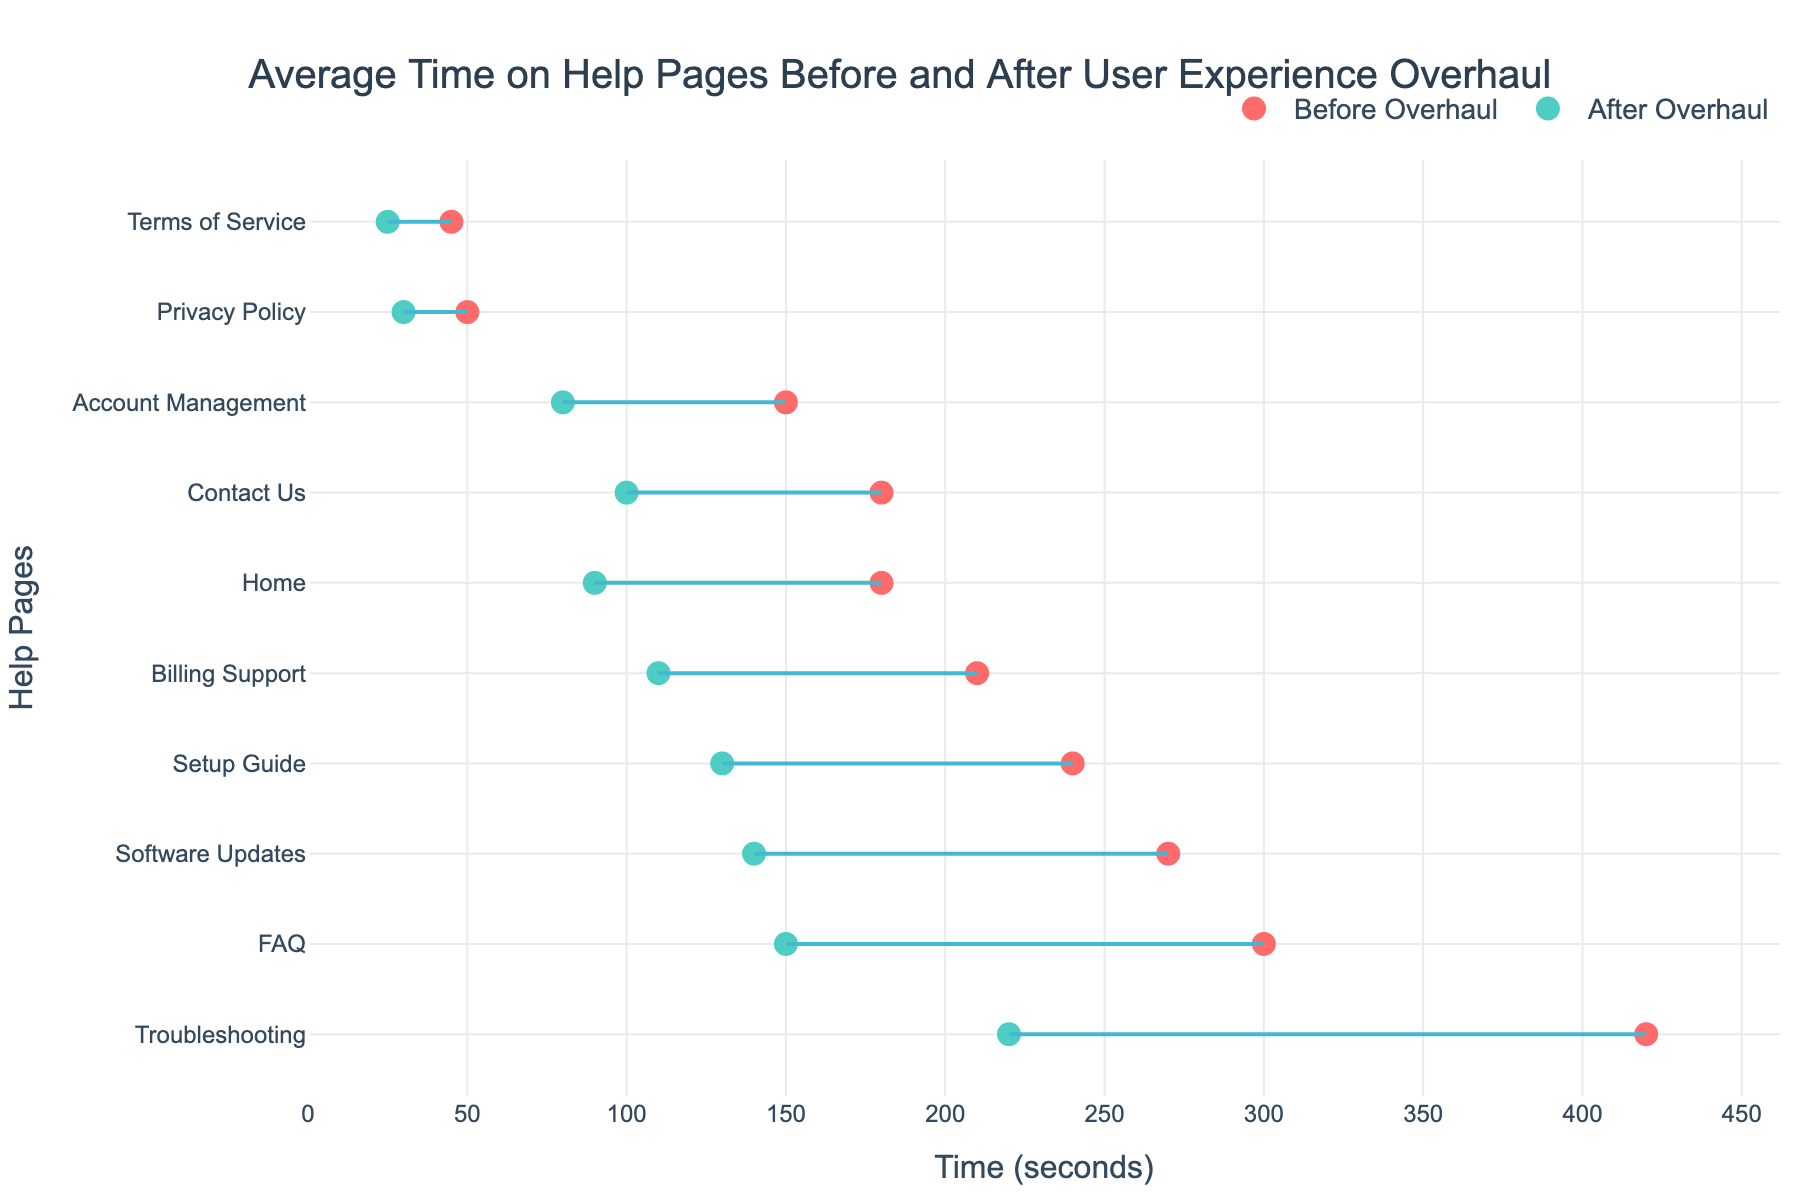What is the range of time users spent on help pages before the overhaul? The range is determined by subtracting the minimum time from the maximum time before the overhaul, which are 45 (Terms of Service) and 420 (Troubleshooting) seconds respectively. 420 - 45 = 375 seconds.
Answer: 375 seconds Which help page saw the greatest reduction in average time after the overhaul? To find this, we compare the difference between "Before Overhaul" and "After Overhaul" for each page. The Troubleshooting page had 420 before and 220 after, resulting in the largest reduction of 200 seconds.
Answer: Troubleshooting How much time did users spend on the Billing Support page after the overhaul? We look at the figure's data points representing the "After Overhaul" time for the Billing Support page. It is shown as 110 seconds.
Answer: 110 seconds Which help page had the smallest improvement in average time spent after the overhaul? To identify the smallest improvement, we look at the page with the lowest difference between "Before Overhaul" and "After Overhaul." The Terms of Service page improved from 45 to 25 seconds, a difference of 20 seconds.
Answer: Terms of Service What categories of help pages are included in the plot? By examining the labels alongside each help page in the figure, we identify the categories as: General Inquiry, Installation, Technical Support, Purchases, Account Related, Legal.
Answer: General Inquiry, Installation, Technical Support, Purchases, Account Related, Legal On which help page did users spend the least amount of time before the overhaul? By referring to the "Before Overhaul" times, we see the Terms of Service page had the lowest value of 45 seconds.
Answer: Terms of Service What is the average time spent on "Technical Support" pages after the overhaul? The "Technical Support" pages are Troubleshooting and Software Updates, with times of 220 and 140 seconds respectively. The average is calculated as (220 + 140) / 2 = 180 seconds.
Answer: 180 seconds Compare the time spent on the FAQ page before and after the overhaul. What is the difference? The FAQ page had 300 seconds before and 150 seconds after the overhaul. The difference is 300 - 150 = 150 seconds.
Answer: 150 seconds Which help page had a higher average time spent before the overhaul, Setup Guide or Billing Support? Comparing the "Before Overhaul" times for Setup Guide (240 seconds) and Billing Support (210 seconds), the Setup Guide had a higher value.
Answer: Setup Guide Which help page under the "Legal" category had a greater reduction in time spent after the overhaul? The Legal category includes Privacy Policy (50 to 30 seconds) and Terms of Service (45 to 25 seconds). The Privacy Policy had a reduction of 20 seconds, while the Terms of Service also had a reduction of 20 seconds. Since they are equal, we note that both reduced equally.
Answer: Both equally 